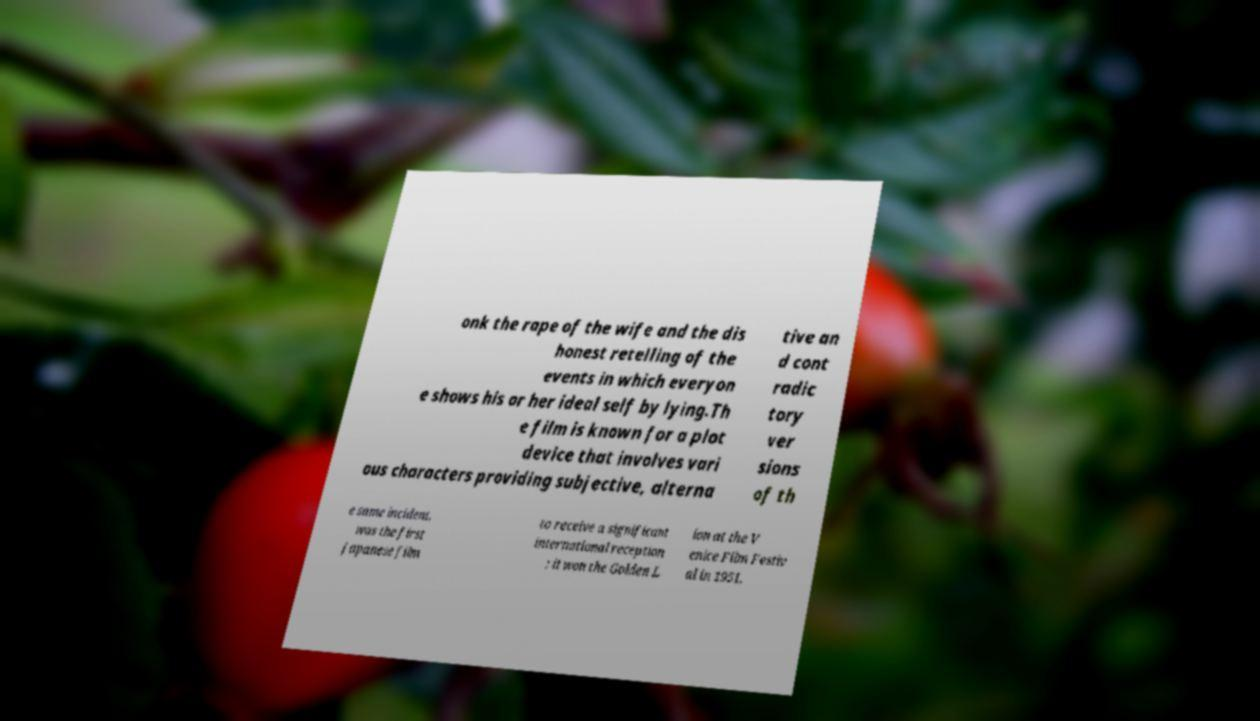I need the written content from this picture converted into text. Can you do that? onk the rape of the wife and the dis honest retelling of the events in which everyon e shows his or her ideal self by lying.Th e film is known for a plot device that involves vari ous characters providing subjective, alterna tive an d cont radic tory ver sions of th e same incident. was the first Japanese film to receive a significant international reception ; it won the Golden L ion at the V enice Film Festiv al in 1951, 